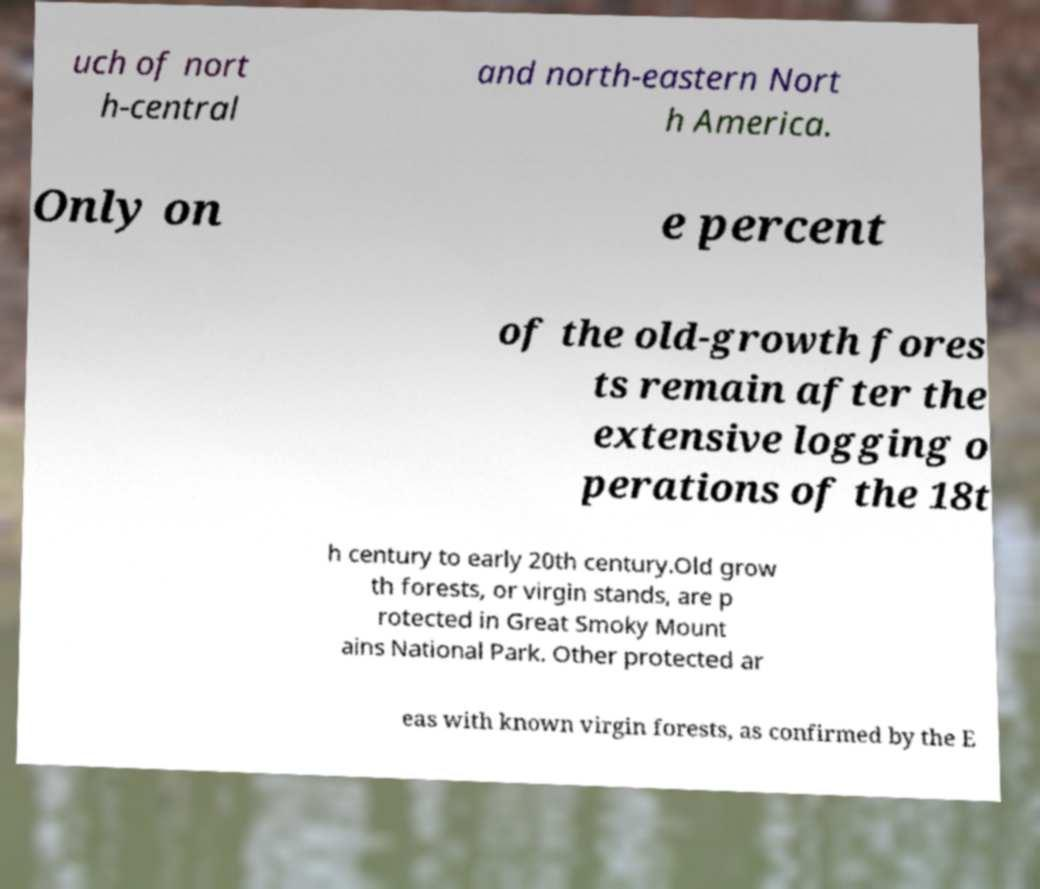For documentation purposes, I need the text within this image transcribed. Could you provide that? uch of nort h-central and north-eastern Nort h America. Only on e percent of the old-growth fores ts remain after the extensive logging o perations of the 18t h century to early 20th century.Old grow th forests, or virgin stands, are p rotected in Great Smoky Mount ains National Park. Other protected ar eas with known virgin forests, as confirmed by the E 